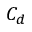Convert formula to latex. <formula><loc_0><loc_0><loc_500><loc_500>C _ { d }</formula> 